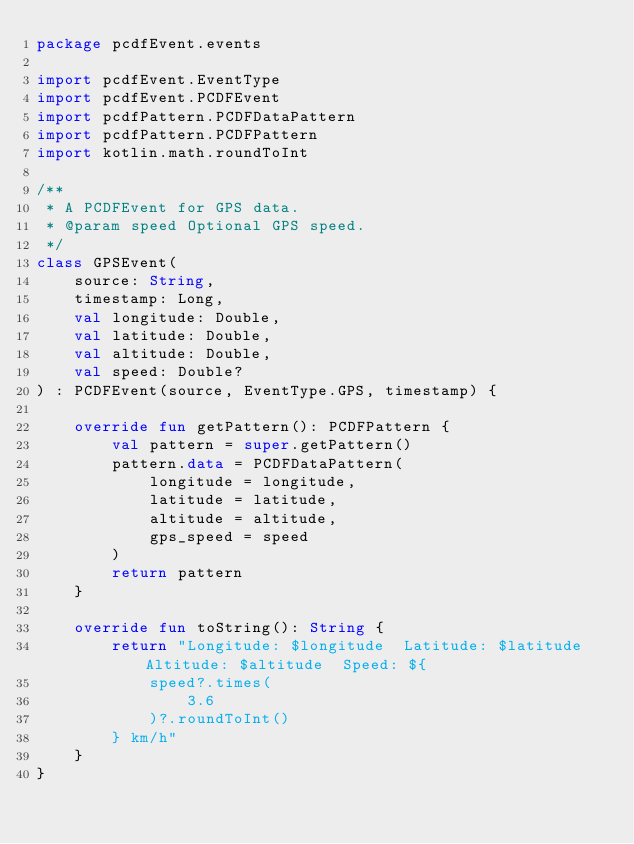Convert code to text. <code><loc_0><loc_0><loc_500><loc_500><_Kotlin_>package pcdfEvent.events

import pcdfEvent.EventType
import pcdfEvent.PCDFEvent
import pcdfPattern.PCDFDataPattern
import pcdfPattern.PCDFPattern
import kotlin.math.roundToInt

/**
 * A PCDFEvent for GPS data.
 * @param speed Optional GPS speed.
 */
class GPSEvent(
    source: String,
    timestamp: Long,
    val longitude: Double,
    val latitude: Double,
    val altitude: Double,
    val speed: Double?
) : PCDFEvent(source, EventType.GPS, timestamp) {

    override fun getPattern(): PCDFPattern {
        val pattern = super.getPattern()
        pattern.data = PCDFDataPattern(
            longitude = longitude,
            latitude = latitude,
            altitude = altitude,
            gps_speed = speed
        )
        return pattern
    }

    override fun toString(): String {
        return "Longitude: $longitude  Latitude: $latitude  Altitude: $altitude  Speed: ${
            speed?.times(
                3.6
            )?.roundToInt()
        } km/h"
    }
}</code> 